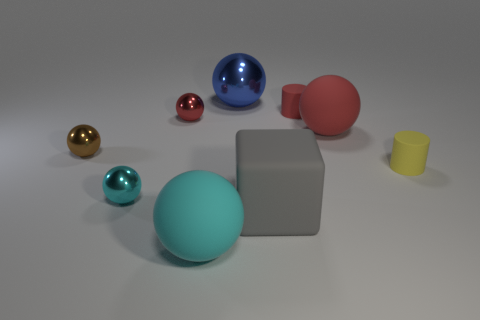Are there more cyan matte balls behind the small brown sphere than tiny cyan shiny balls?
Provide a succinct answer. No. What number of other things are the same shape as the tiny brown metal thing?
Your answer should be compact. 5. There is a big object that is behind the large gray thing and in front of the big metallic sphere; what is its material?
Offer a very short reply. Rubber. What number of objects are either rubber blocks or large yellow metallic balls?
Offer a very short reply. 1. Are there more tiny purple cylinders than small cyan metal things?
Offer a very short reply. No. What is the size of the red matte thing that is on the right side of the small matte thing behind the brown object?
Make the answer very short. Large. What is the color of the other big metallic object that is the same shape as the brown shiny thing?
Your answer should be very brief. Blue. What size is the yellow cylinder?
Keep it short and to the point. Small. What number of blocks are either brown rubber things or cyan matte things?
Make the answer very short. 0. The other red metal object that is the same shape as the large metal thing is what size?
Provide a succinct answer. Small. 